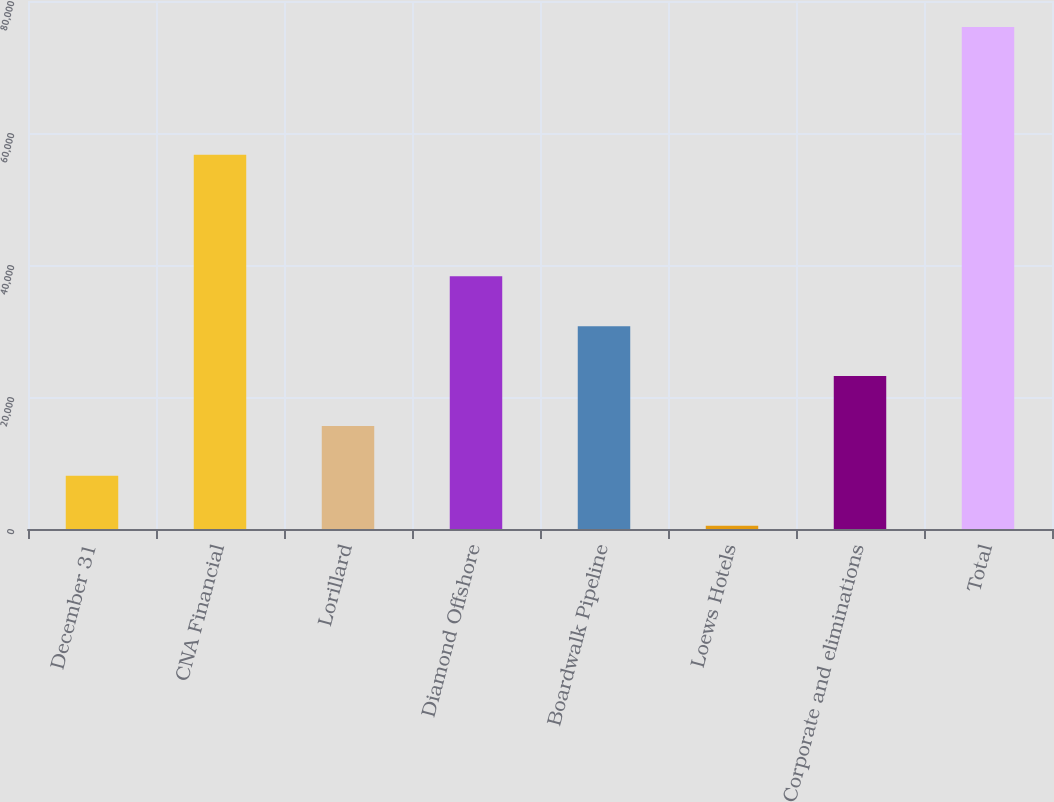Convert chart. <chart><loc_0><loc_0><loc_500><loc_500><bar_chart><fcel>December 31<fcel>CNA Financial<fcel>Lorillard<fcel>Diamond Offshore<fcel>Boardwalk Pipeline<fcel>Loews Hotels<fcel>Corporate and eliminations<fcel>Total<nl><fcel>8057<fcel>56692<fcel>15615<fcel>38289<fcel>30731<fcel>499<fcel>23173<fcel>76079<nl></chart> 